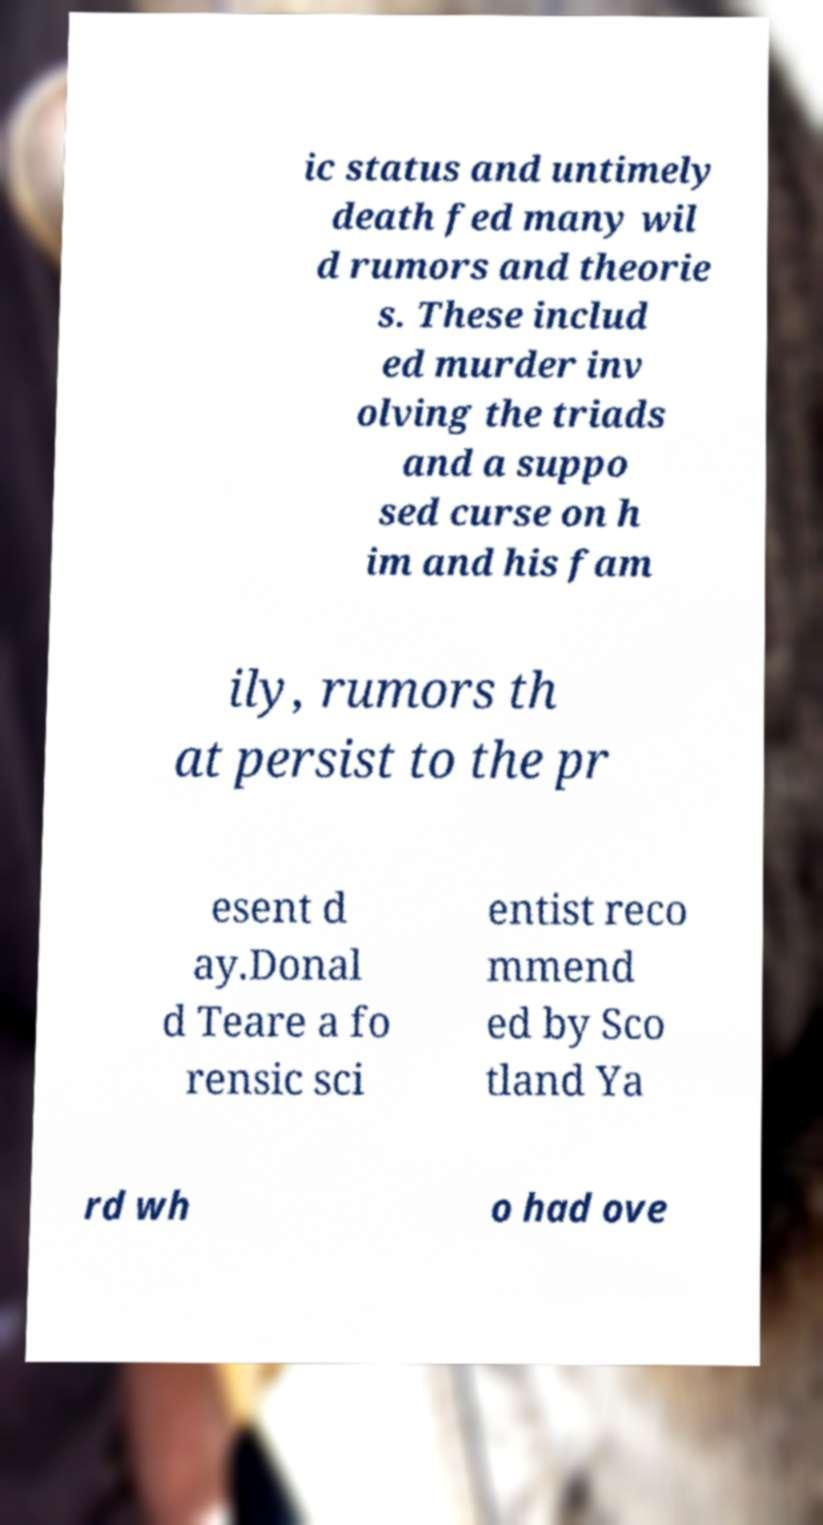Please identify and transcribe the text found in this image. ic status and untimely death fed many wil d rumors and theorie s. These includ ed murder inv olving the triads and a suppo sed curse on h im and his fam ily, rumors th at persist to the pr esent d ay.Donal d Teare a fo rensic sci entist reco mmend ed by Sco tland Ya rd wh o had ove 